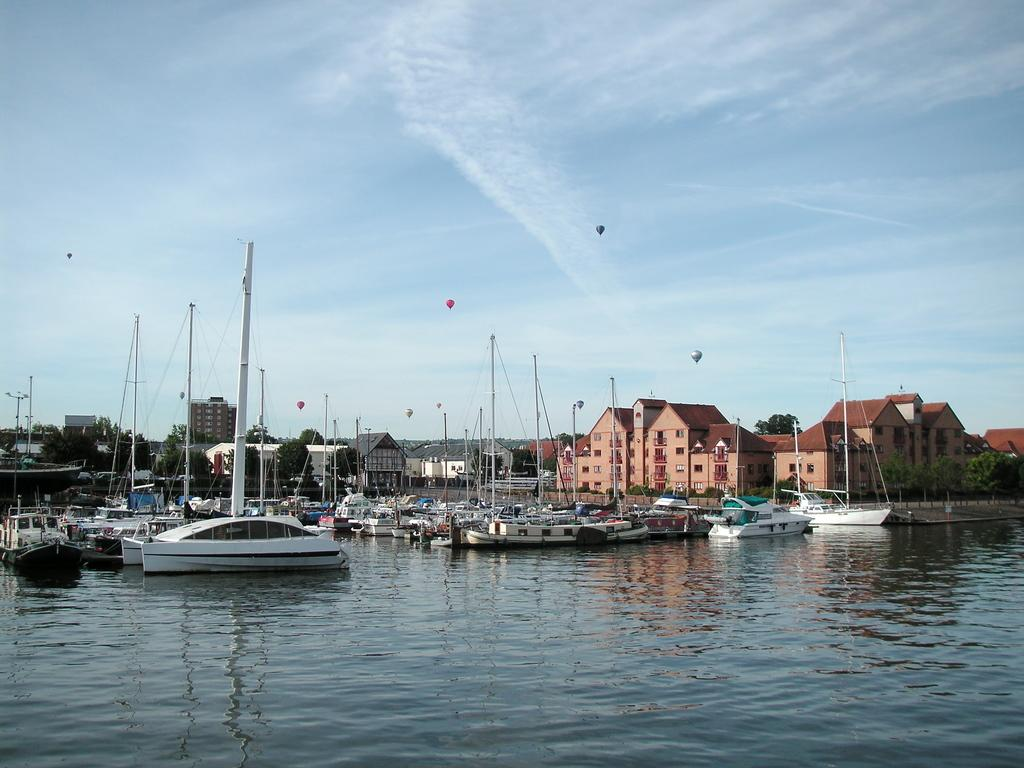What is the primary element in the image? There is water in the image. What is floating on the water? There are boats in the water. What can be seen in the background of the image? There are trees and buildings in the background of the image. What is visible in the sky? There are clouds visible in the image, and the sky is also visible. What else is present in the air in the image? There are balloons in the air in the image. What type of bead is being used to tie the boot in the image? There is no bead or boot present in the image; it features water, boats, trees, buildings, clouds, the sky, and balloons. 